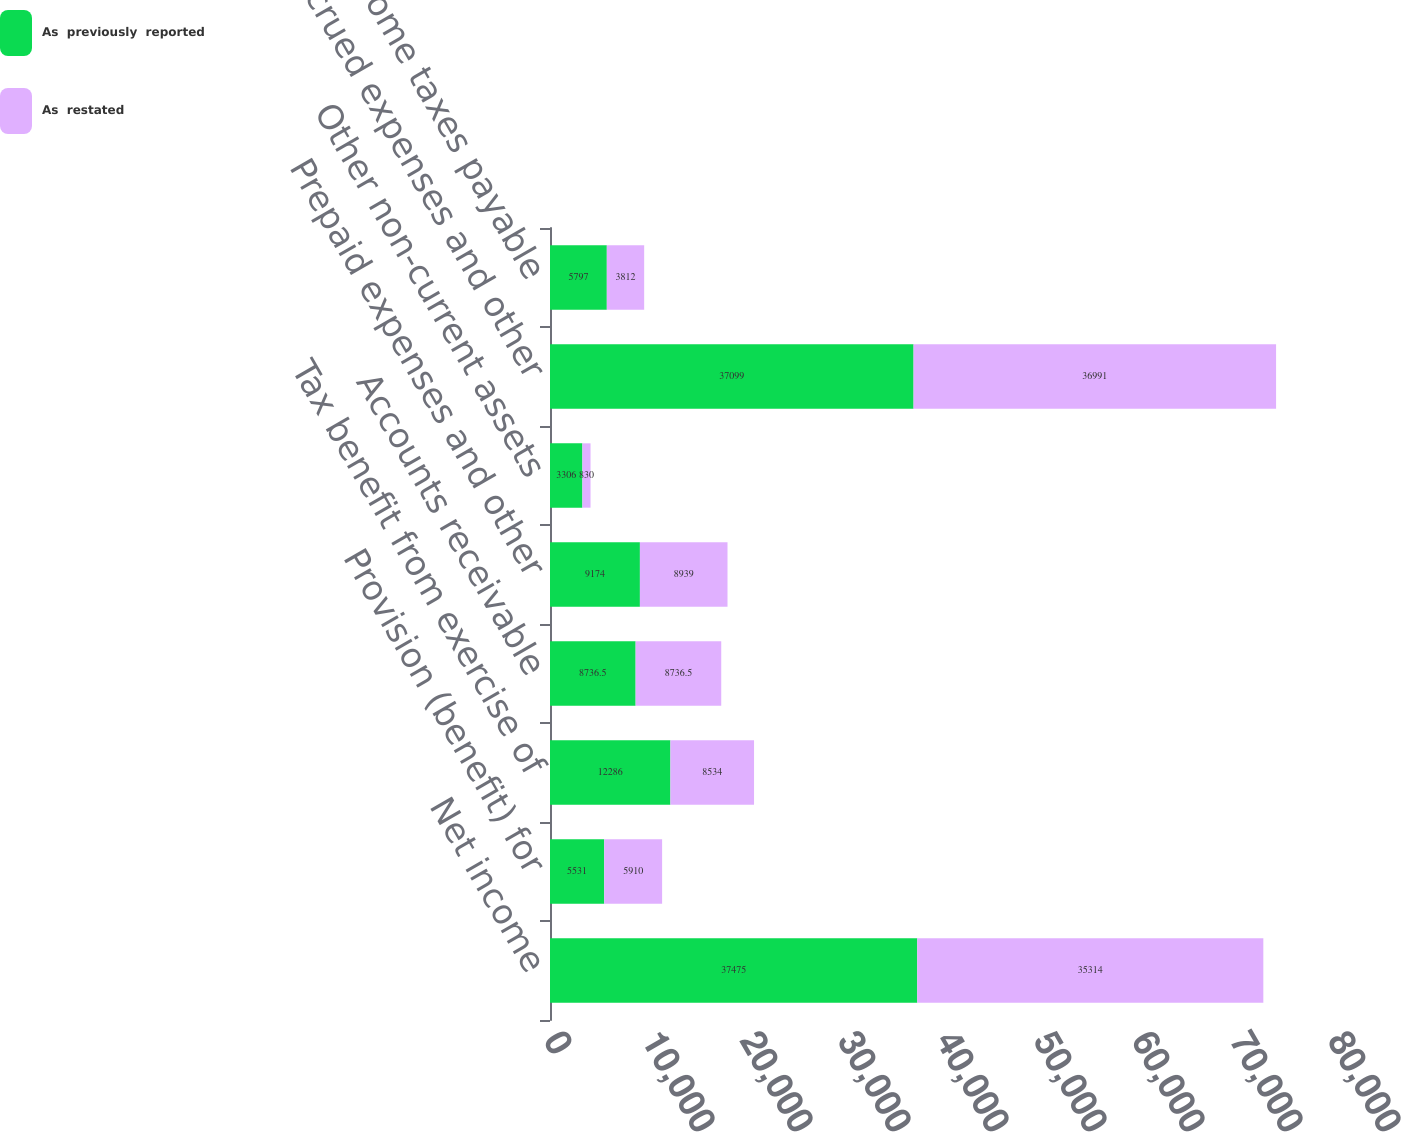Convert chart to OTSL. <chart><loc_0><loc_0><loc_500><loc_500><stacked_bar_chart><ecel><fcel>Net income<fcel>Provision (benefit) for<fcel>Tax benefit from exercise of<fcel>Accounts receivable<fcel>Prepaid expenses and other<fcel>Other non-current assets<fcel>Accrued expenses and other<fcel>Income taxes payable<nl><fcel>As  previously  reported<fcel>37475<fcel>5531<fcel>12286<fcel>8736.5<fcel>9174<fcel>3306<fcel>37099<fcel>5797<nl><fcel>As  restated<fcel>35314<fcel>5910<fcel>8534<fcel>8736.5<fcel>8939<fcel>830<fcel>36991<fcel>3812<nl></chart> 